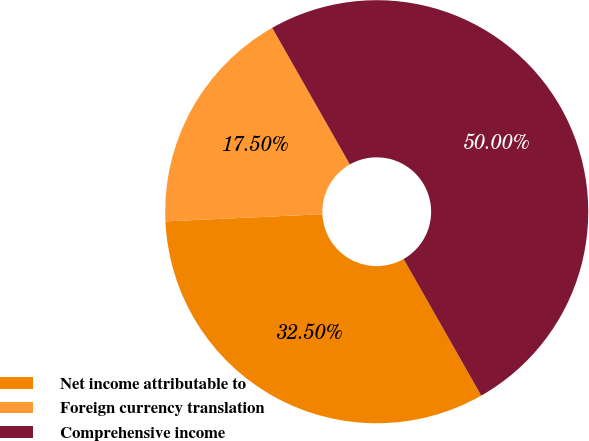<chart> <loc_0><loc_0><loc_500><loc_500><pie_chart><fcel>Net income attributable to<fcel>Foreign currency translation<fcel>Comprehensive income<nl><fcel>32.5%<fcel>17.5%<fcel>50.0%<nl></chart> 